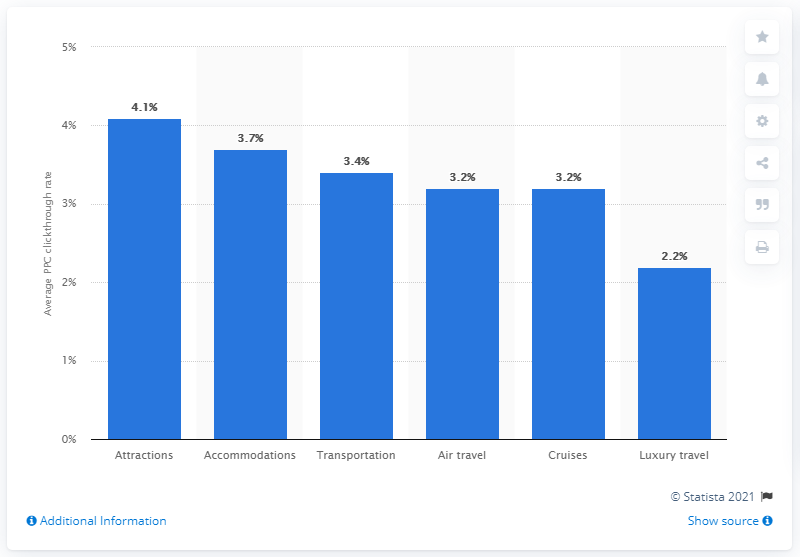Point out several critical features in this image. The average clickthrough rate of the attractions sector was 4.1%. 